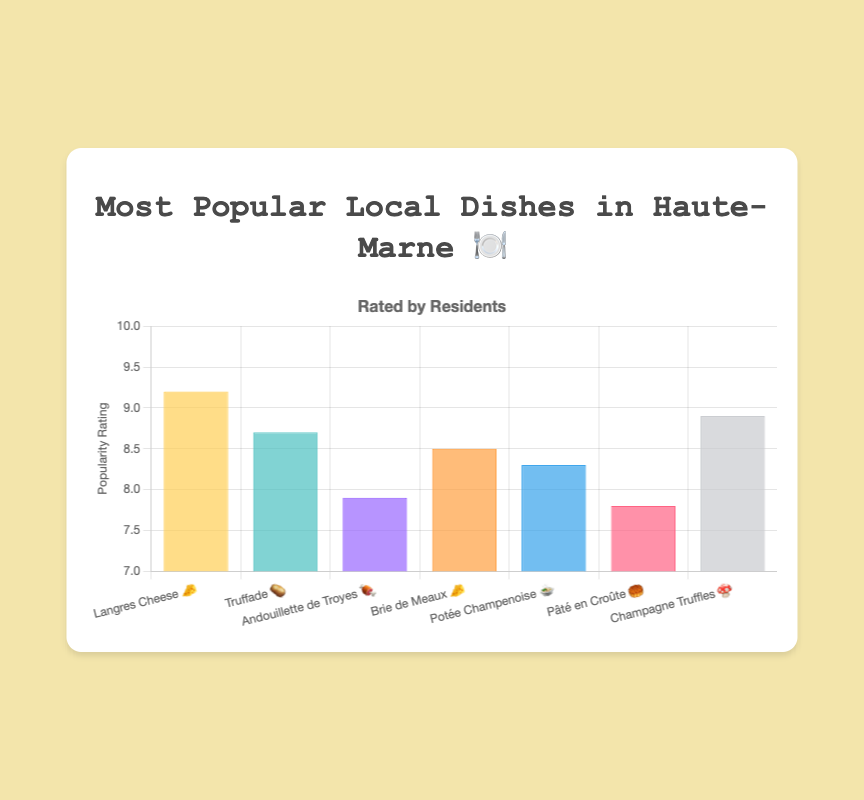Which dish has the highest popularity rating in Haute-Marne? The chart shows Langres Cheese 🧀 has the highest bar.
Answer: Langres Cheese 🧀 What is the popularity rating of Champagne Truffles? Find the bar labeled "Champagne Truffles 🍄" and read its height.
Answer: 8.9 How many dishes have a popularity rating above 8.0? Count the bars that extend above the 8.0 mark.
Answer: 5 Among the dishes listed, which one has the lowest popularity rating? Identify the shortest bar in the chart.
Answer: Pâté en Croûte 🥮 Compare the popularity ratings of Brie de Meaux and Potée Champenoise. Which one is higher and by how much? Brie de Meaux 🧀 has a height of 8.5, and Potée Champenoise 🍲 has 8.3. The difference is 8.5 - 8.3.
Answer: Brie de Meaux by 0.2 What’s the average popularity rating of all the dishes? Add all the ratings (9.2 + 8.7 + 7.9 + 8.5 + 8.3 + 7.8 + 8.9) and divide by the number of dishes (7).
Answer: 8.47 Which dish has a popularity rating closest to 8.0? Identify the bar closest to the 8.0 mark. The closest rating is 7.9 from Andouillette de Troyes 🍖.
Answer: Andouillette de Troyes 🍖 Which two dishes have the same type of emoji and what are their popularity ratings? Find the dishes with the 🧀 emoji: Langres Cheese 🧀 (9.2) and Brie de Meaux 🧀 (8.5).
Answer: Langres Cheese (9.2) and Brie de Meaux (8.5) By how much does the popularity rating of Langres Cheese exceed that of Pâté en Croûte? Subtract the rating of Pâté en Croûte 🥮 from Langres Cheese 🧀: 9.2 - 7.8.
Answer: 1.4 What’s the total combined popularity rating of Truffade, Andouillette de Troyes, and Champagne Truffles? Add the ratings: 8.7 (Truffade 🥔) + 7.9 (Andouillette de Troyes 🍖) + 8.9 (Champagne Truffles 🍄).
Answer: 25.5 